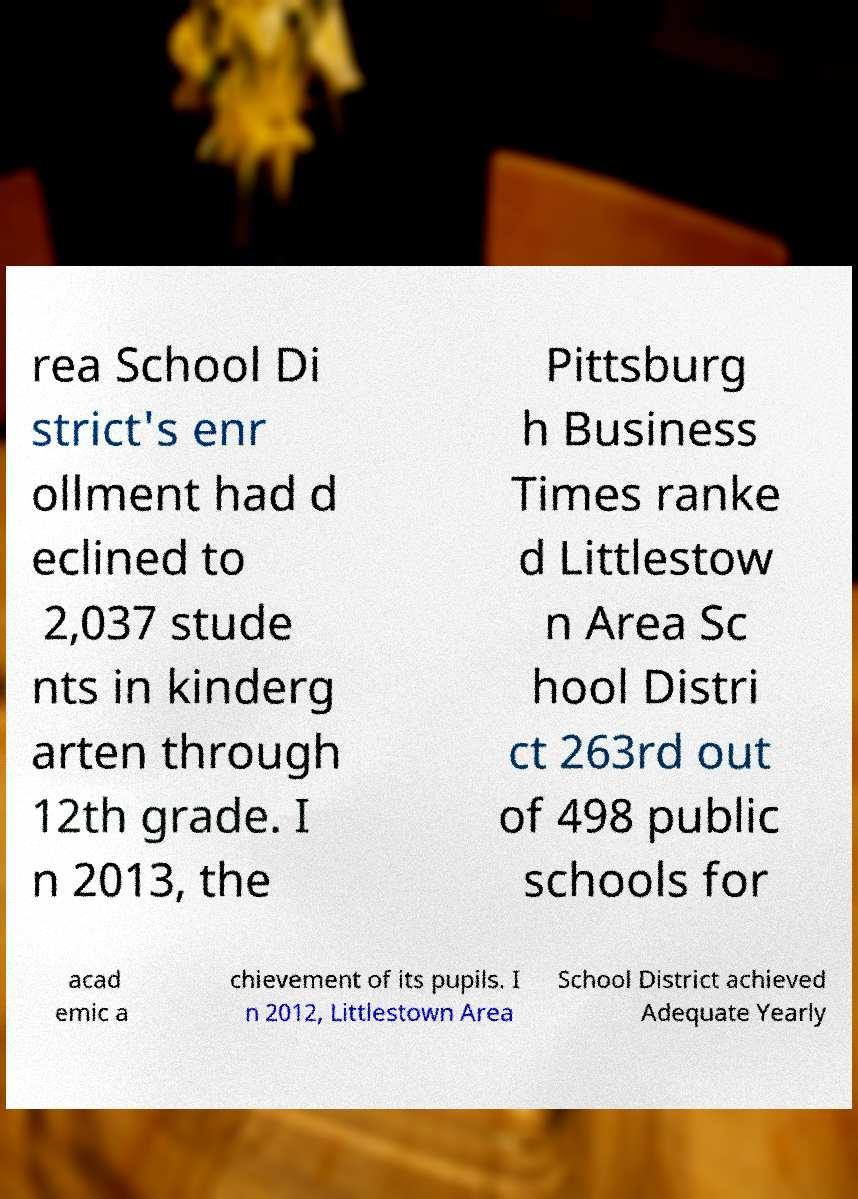What messages or text are displayed in this image? I need them in a readable, typed format. rea School Di strict's enr ollment had d eclined to 2,037 stude nts in kinderg arten through 12th grade. I n 2013, the Pittsburg h Business Times ranke d Littlestow n Area Sc hool Distri ct 263rd out of 498 public schools for acad emic a chievement of its pupils. I n 2012, Littlestown Area School District achieved Adequate Yearly 